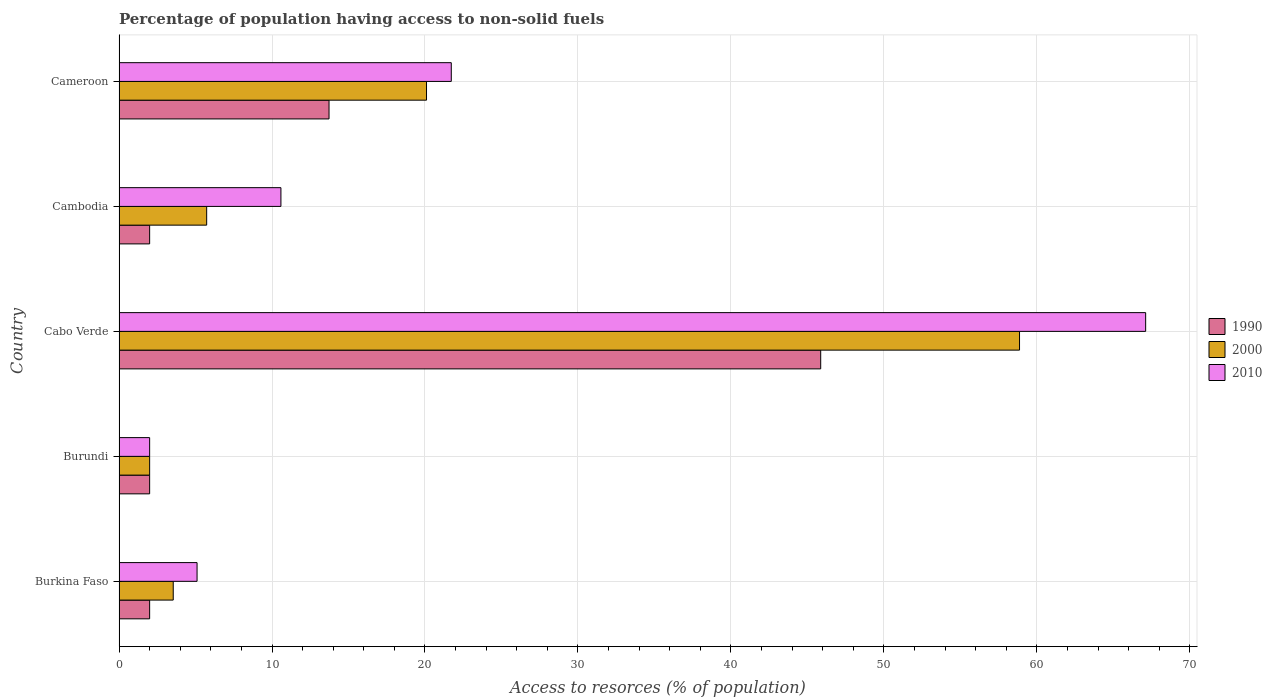How many different coloured bars are there?
Offer a very short reply. 3. Are the number of bars on each tick of the Y-axis equal?
Ensure brevity in your answer.  Yes. How many bars are there on the 1st tick from the bottom?
Offer a terse response. 3. What is the label of the 1st group of bars from the top?
Offer a very short reply. Cameroon. What is the percentage of population having access to non-solid fuels in 1990 in Cabo Verde?
Your answer should be compact. 45.87. Across all countries, what is the maximum percentage of population having access to non-solid fuels in 2000?
Provide a short and direct response. 58.87. Across all countries, what is the minimum percentage of population having access to non-solid fuels in 2000?
Your response must be concise. 2. In which country was the percentage of population having access to non-solid fuels in 2010 maximum?
Offer a very short reply. Cabo Verde. In which country was the percentage of population having access to non-solid fuels in 2010 minimum?
Give a very brief answer. Burundi. What is the total percentage of population having access to non-solid fuels in 1990 in the graph?
Make the answer very short. 65.6. What is the difference between the percentage of population having access to non-solid fuels in 2010 in Burkina Faso and that in Cameroon?
Your answer should be very brief. -16.62. What is the difference between the percentage of population having access to non-solid fuels in 2010 in Burkina Faso and the percentage of population having access to non-solid fuels in 1990 in Cabo Verde?
Provide a short and direct response. -40.77. What is the average percentage of population having access to non-solid fuels in 2010 per country?
Keep it short and to the point. 21.3. What is the difference between the percentage of population having access to non-solid fuels in 2000 and percentage of population having access to non-solid fuels in 1990 in Cameroon?
Ensure brevity in your answer.  6.37. What is the ratio of the percentage of population having access to non-solid fuels in 2010 in Burkina Faso to that in Burundi?
Make the answer very short. 2.55. Is the percentage of population having access to non-solid fuels in 1990 in Burkina Faso less than that in Burundi?
Offer a very short reply. No. Is the difference between the percentage of population having access to non-solid fuels in 2000 in Cambodia and Cameroon greater than the difference between the percentage of population having access to non-solid fuels in 1990 in Cambodia and Cameroon?
Ensure brevity in your answer.  No. What is the difference between the highest and the second highest percentage of population having access to non-solid fuels in 2010?
Your answer should be very brief. 45.4. What is the difference between the highest and the lowest percentage of population having access to non-solid fuels in 1990?
Offer a terse response. 43.87. In how many countries, is the percentage of population having access to non-solid fuels in 1990 greater than the average percentage of population having access to non-solid fuels in 1990 taken over all countries?
Ensure brevity in your answer.  2. Is the sum of the percentage of population having access to non-solid fuels in 1990 in Burundi and Cabo Verde greater than the maximum percentage of population having access to non-solid fuels in 2010 across all countries?
Keep it short and to the point. No. How many bars are there?
Provide a succinct answer. 15. Are all the bars in the graph horizontal?
Your response must be concise. Yes. How many countries are there in the graph?
Your response must be concise. 5. What is the difference between two consecutive major ticks on the X-axis?
Keep it short and to the point. 10. Are the values on the major ticks of X-axis written in scientific E-notation?
Ensure brevity in your answer.  No. Does the graph contain any zero values?
Keep it short and to the point. No. How are the legend labels stacked?
Make the answer very short. Vertical. What is the title of the graph?
Offer a terse response. Percentage of population having access to non-solid fuels. What is the label or title of the X-axis?
Your answer should be compact. Access to resorces (% of population). What is the Access to resorces (% of population) of 1990 in Burkina Faso?
Make the answer very short. 2. What is the Access to resorces (% of population) in 2000 in Burkina Faso?
Your answer should be very brief. 3.54. What is the Access to resorces (% of population) of 2010 in Burkina Faso?
Offer a terse response. 5.1. What is the Access to resorces (% of population) in 1990 in Burundi?
Provide a succinct answer. 2. What is the Access to resorces (% of population) of 2000 in Burundi?
Your answer should be very brief. 2. What is the Access to resorces (% of population) of 2010 in Burundi?
Your response must be concise. 2. What is the Access to resorces (% of population) in 1990 in Cabo Verde?
Provide a succinct answer. 45.87. What is the Access to resorces (% of population) of 2000 in Cabo Verde?
Your answer should be compact. 58.87. What is the Access to resorces (% of population) of 2010 in Cabo Verde?
Make the answer very short. 67.11. What is the Access to resorces (% of population) in 1990 in Cambodia?
Ensure brevity in your answer.  2. What is the Access to resorces (% of population) in 2000 in Cambodia?
Your answer should be very brief. 5.73. What is the Access to resorces (% of population) in 2010 in Cambodia?
Your answer should be compact. 10.58. What is the Access to resorces (% of population) of 1990 in Cameroon?
Ensure brevity in your answer.  13.73. What is the Access to resorces (% of population) of 2000 in Cameroon?
Keep it short and to the point. 20.1. What is the Access to resorces (% of population) of 2010 in Cameroon?
Give a very brief answer. 21.72. Across all countries, what is the maximum Access to resorces (% of population) in 1990?
Offer a terse response. 45.87. Across all countries, what is the maximum Access to resorces (% of population) in 2000?
Your answer should be very brief. 58.87. Across all countries, what is the maximum Access to resorces (% of population) of 2010?
Ensure brevity in your answer.  67.11. Across all countries, what is the minimum Access to resorces (% of population) in 1990?
Ensure brevity in your answer.  2. Across all countries, what is the minimum Access to resorces (% of population) of 2000?
Your answer should be very brief. 2. Across all countries, what is the minimum Access to resorces (% of population) of 2010?
Provide a short and direct response. 2. What is the total Access to resorces (% of population) in 1990 in the graph?
Provide a short and direct response. 65.6. What is the total Access to resorces (% of population) of 2000 in the graph?
Provide a short and direct response. 90.24. What is the total Access to resorces (% of population) in 2010 in the graph?
Give a very brief answer. 106.52. What is the difference between the Access to resorces (% of population) in 1990 in Burkina Faso and that in Burundi?
Keep it short and to the point. 0. What is the difference between the Access to resorces (% of population) in 2000 in Burkina Faso and that in Burundi?
Offer a terse response. 1.54. What is the difference between the Access to resorces (% of population) in 2010 in Burkina Faso and that in Burundi?
Your response must be concise. 3.1. What is the difference between the Access to resorces (% of population) in 1990 in Burkina Faso and that in Cabo Verde?
Your answer should be very brief. -43.87. What is the difference between the Access to resorces (% of population) of 2000 in Burkina Faso and that in Cabo Verde?
Give a very brief answer. -55.33. What is the difference between the Access to resorces (% of population) of 2010 in Burkina Faso and that in Cabo Verde?
Ensure brevity in your answer.  -62.01. What is the difference between the Access to resorces (% of population) in 1990 in Burkina Faso and that in Cambodia?
Provide a succinct answer. 0. What is the difference between the Access to resorces (% of population) in 2000 in Burkina Faso and that in Cambodia?
Your response must be concise. -2.19. What is the difference between the Access to resorces (% of population) in 2010 in Burkina Faso and that in Cambodia?
Give a very brief answer. -5.48. What is the difference between the Access to resorces (% of population) in 1990 in Burkina Faso and that in Cameroon?
Provide a succinct answer. -11.73. What is the difference between the Access to resorces (% of population) of 2000 in Burkina Faso and that in Cameroon?
Your response must be concise. -16.56. What is the difference between the Access to resorces (% of population) of 2010 in Burkina Faso and that in Cameroon?
Make the answer very short. -16.62. What is the difference between the Access to resorces (% of population) of 1990 in Burundi and that in Cabo Verde?
Provide a succinct answer. -43.87. What is the difference between the Access to resorces (% of population) in 2000 in Burundi and that in Cabo Verde?
Offer a very short reply. -56.87. What is the difference between the Access to resorces (% of population) in 2010 in Burundi and that in Cabo Verde?
Make the answer very short. -65.11. What is the difference between the Access to resorces (% of population) in 2000 in Burundi and that in Cambodia?
Give a very brief answer. -3.73. What is the difference between the Access to resorces (% of population) of 2010 in Burundi and that in Cambodia?
Provide a succinct answer. -8.58. What is the difference between the Access to resorces (% of population) in 1990 in Burundi and that in Cameroon?
Provide a succinct answer. -11.73. What is the difference between the Access to resorces (% of population) in 2000 in Burundi and that in Cameroon?
Offer a very short reply. -18.1. What is the difference between the Access to resorces (% of population) in 2010 in Burundi and that in Cameroon?
Make the answer very short. -19.72. What is the difference between the Access to resorces (% of population) in 1990 in Cabo Verde and that in Cambodia?
Offer a very short reply. 43.87. What is the difference between the Access to resorces (% of population) of 2000 in Cabo Verde and that in Cambodia?
Your answer should be very brief. 53.14. What is the difference between the Access to resorces (% of population) in 2010 in Cabo Verde and that in Cambodia?
Your answer should be very brief. 56.53. What is the difference between the Access to resorces (% of population) of 1990 in Cabo Verde and that in Cameroon?
Your answer should be very brief. 32.14. What is the difference between the Access to resorces (% of population) in 2000 in Cabo Verde and that in Cameroon?
Ensure brevity in your answer.  38.77. What is the difference between the Access to resorces (% of population) in 2010 in Cabo Verde and that in Cameroon?
Ensure brevity in your answer.  45.4. What is the difference between the Access to resorces (% of population) of 1990 in Cambodia and that in Cameroon?
Provide a succinct answer. -11.73. What is the difference between the Access to resorces (% of population) of 2000 in Cambodia and that in Cameroon?
Your answer should be compact. -14.37. What is the difference between the Access to resorces (% of population) in 2010 in Cambodia and that in Cameroon?
Offer a very short reply. -11.14. What is the difference between the Access to resorces (% of population) in 1990 in Burkina Faso and the Access to resorces (% of population) in 2000 in Burundi?
Provide a succinct answer. 0. What is the difference between the Access to resorces (% of population) of 1990 in Burkina Faso and the Access to resorces (% of population) of 2010 in Burundi?
Provide a succinct answer. 0. What is the difference between the Access to resorces (% of population) in 2000 in Burkina Faso and the Access to resorces (% of population) in 2010 in Burundi?
Your response must be concise. 1.54. What is the difference between the Access to resorces (% of population) of 1990 in Burkina Faso and the Access to resorces (% of population) of 2000 in Cabo Verde?
Provide a short and direct response. -56.87. What is the difference between the Access to resorces (% of population) in 1990 in Burkina Faso and the Access to resorces (% of population) in 2010 in Cabo Verde?
Make the answer very short. -65.11. What is the difference between the Access to resorces (% of population) in 2000 in Burkina Faso and the Access to resorces (% of population) in 2010 in Cabo Verde?
Make the answer very short. -63.57. What is the difference between the Access to resorces (% of population) of 1990 in Burkina Faso and the Access to resorces (% of population) of 2000 in Cambodia?
Give a very brief answer. -3.73. What is the difference between the Access to resorces (% of population) in 1990 in Burkina Faso and the Access to resorces (% of population) in 2010 in Cambodia?
Provide a short and direct response. -8.58. What is the difference between the Access to resorces (% of population) of 2000 in Burkina Faso and the Access to resorces (% of population) of 2010 in Cambodia?
Make the answer very short. -7.04. What is the difference between the Access to resorces (% of population) in 1990 in Burkina Faso and the Access to resorces (% of population) in 2000 in Cameroon?
Keep it short and to the point. -18.1. What is the difference between the Access to resorces (% of population) of 1990 in Burkina Faso and the Access to resorces (% of population) of 2010 in Cameroon?
Offer a very short reply. -19.72. What is the difference between the Access to resorces (% of population) of 2000 in Burkina Faso and the Access to resorces (% of population) of 2010 in Cameroon?
Your answer should be very brief. -18.18. What is the difference between the Access to resorces (% of population) of 1990 in Burundi and the Access to resorces (% of population) of 2000 in Cabo Verde?
Keep it short and to the point. -56.87. What is the difference between the Access to resorces (% of population) of 1990 in Burundi and the Access to resorces (% of population) of 2010 in Cabo Verde?
Provide a succinct answer. -65.11. What is the difference between the Access to resorces (% of population) in 2000 in Burundi and the Access to resorces (% of population) in 2010 in Cabo Verde?
Ensure brevity in your answer.  -65.11. What is the difference between the Access to resorces (% of population) of 1990 in Burundi and the Access to resorces (% of population) of 2000 in Cambodia?
Provide a short and direct response. -3.73. What is the difference between the Access to resorces (% of population) in 1990 in Burundi and the Access to resorces (% of population) in 2010 in Cambodia?
Make the answer very short. -8.58. What is the difference between the Access to resorces (% of population) in 2000 in Burundi and the Access to resorces (% of population) in 2010 in Cambodia?
Provide a succinct answer. -8.58. What is the difference between the Access to resorces (% of population) of 1990 in Burundi and the Access to resorces (% of population) of 2000 in Cameroon?
Your response must be concise. -18.1. What is the difference between the Access to resorces (% of population) in 1990 in Burundi and the Access to resorces (% of population) in 2010 in Cameroon?
Your answer should be very brief. -19.72. What is the difference between the Access to resorces (% of population) of 2000 in Burundi and the Access to resorces (% of population) of 2010 in Cameroon?
Give a very brief answer. -19.72. What is the difference between the Access to resorces (% of population) in 1990 in Cabo Verde and the Access to resorces (% of population) in 2000 in Cambodia?
Your answer should be compact. 40.14. What is the difference between the Access to resorces (% of population) of 1990 in Cabo Verde and the Access to resorces (% of population) of 2010 in Cambodia?
Your answer should be very brief. 35.29. What is the difference between the Access to resorces (% of population) of 2000 in Cabo Verde and the Access to resorces (% of population) of 2010 in Cambodia?
Keep it short and to the point. 48.29. What is the difference between the Access to resorces (% of population) of 1990 in Cabo Verde and the Access to resorces (% of population) of 2000 in Cameroon?
Your answer should be compact. 25.77. What is the difference between the Access to resorces (% of population) of 1990 in Cabo Verde and the Access to resorces (% of population) of 2010 in Cameroon?
Make the answer very short. 24.15. What is the difference between the Access to resorces (% of population) in 2000 in Cabo Verde and the Access to resorces (% of population) in 2010 in Cameroon?
Offer a terse response. 37.15. What is the difference between the Access to resorces (% of population) of 1990 in Cambodia and the Access to resorces (% of population) of 2000 in Cameroon?
Provide a succinct answer. -18.1. What is the difference between the Access to resorces (% of population) in 1990 in Cambodia and the Access to resorces (% of population) in 2010 in Cameroon?
Offer a very short reply. -19.72. What is the difference between the Access to resorces (% of population) in 2000 in Cambodia and the Access to resorces (% of population) in 2010 in Cameroon?
Make the answer very short. -15.99. What is the average Access to resorces (% of population) of 1990 per country?
Your response must be concise. 13.12. What is the average Access to resorces (% of population) in 2000 per country?
Ensure brevity in your answer.  18.05. What is the average Access to resorces (% of population) in 2010 per country?
Offer a very short reply. 21.3. What is the difference between the Access to resorces (% of population) in 1990 and Access to resorces (% of population) in 2000 in Burkina Faso?
Keep it short and to the point. -1.54. What is the difference between the Access to resorces (% of population) of 1990 and Access to resorces (% of population) of 2010 in Burkina Faso?
Your answer should be very brief. -3.1. What is the difference between the Access to resorces (% of population) of 2000 and Access to resorces (% of population) of 2010 in Burkina Faso?
Offer a terse response. -1.56. What is the difference between the Access to resorces (% of population) in 1990 and Access to resorces (% of population) in 2000 in Burundi?
Keep it short and to the point. 0. What is the difference between the Access to resorces (% of population) in 1990 and Access to resorces (% of population) in 2000 in Cabo Verde?
Provide a succinct answer. -13. What is the difference between the Access to resorces (% of population) of 1990 and Access to resorces (% of population) of 2010 in Cabo Verde?
Keep it short and to the point. -21.24. What is the difference between the Access to resorces (% of population) in 2000 and Access to resorces (% of population) in 2010 in Cabo Verde?
Ensure brevity in your answer.  -8.25. What is the difference between the Access to resorces (% of population) in 1990 and Access to resorces (% of population) in 2000 in Cambodia?
Offer a terse response. -3.73. What is the difference between the Access to resorces (% of population) in 1990 and Access to resorces (% of population) in 2010 in Cambodia?
Your response must be concise. -8.58. What is the difference between the Access to resorces (% of population) in 2000 and Access to resorces (% of population) in 2010 in Cambodia?
Provide a short and direct response. -4.85. What is the difference between the Access to resorces (% of population) of 1990 and Access to resorces (% of population) of 2000 in Cameroon?
Provide a short and direct response. -6.37. What is the difference between the Access to resorces (% of population) in 1990 and Access to resorces (% of population) in 2010 in Cameroon?
Offer a terse response. -7.99. What is the difference between the Access to resorces (% of population) of 2000 and Access to resorces (% of population) of 2010 in Cameroon?
Provide a short and direct response. -1.62. What is the ratio of the Access to resorces (% of population) in 2000 in Burkina Faso to that in Burundi?
Offer a very short reply. 1.77. What is the ratio of the Access to resorces (% of population) of 2010 in Burkina Faso to that in Burundi?
Make the answer very short. 2.55. What is the ratio of the Access to resorces (% of population) of 1990 in Burkina Faso to that in Cabo Verde?
Give a very brief answer. 0.04. What is the ratio of the Access to resorces (% of population) in 2000 in Burkina Faso to that in Cabo Verde?
Make the answer very short. 0.06. What is the ratio of the Access to resorces (% of population) of 2010 in Burkina Faso to that in Cabo Verde?
Your response must be concise. 0.08. What is the ratio of the Access to resorces (% of population) in 1990 in Burkina Faso to that in Cambodia?
Provide a short and direct response. 1. What is the ratio of the Access to resorces (% of population) of 2000 in Burkina Faso to that in Cambodia?
Offer a terse response. 0.62. What is the ratio of the Access to resorces (% of population) in 2010 in Burkina Faso to that in Cambodia?
Provide a succinct answer. 0.48. What is the ratio of the Access to resorces (% of population) in 1990 in Burkina Faso to that in Cameroon?
Ensure brevity in your answer.  0.15. What is the ratio of the Access to resorces (% of population) of 2000 in Burkina Faso to that in Cameroon?
Provide a succinct answer. 0.18. What is the ratio of the Access to resorces (% of population) in 2010 in Burkina Faso to that in Cameroon?
Your answer should be very brief. 0.23. What is the ratio of the Access to resorces (% of population) of 1990 in Burundi to that in Cabo Verde?
Ensure brevity in your answer.  0.04. What is the ratio of the Access to resorces (% of population) in 2000 in Burundi to that in Cabo Verde?
Keep it short and to the point. 0.03. What is the ratio of the Access to resorces (% of population) in 2010 in Burundi to that in Cabo Verde?
Your answer should be very brief. 0.03. What is the ratio of the Access to resorces (% of population) in 2000 in Burundi to that in Cambodia?
Keep it short and to the point. 0.35. What is the ratio of the Access to resorces (% of population) in 2010 in Burundi to that in Cambodia?
Offer a terse response. 0.19. What is the ratio of the Access to resorces (% of population) of 1990 in Burundi to that in Cameroon?
Provide a succinct answer. 0.15. What is the ratio of the Access to resorces (% of population) of 2000 in Burundi to that in Cameroon?
Your answer should be compact. 0.1. What is the ratio of the Access to resorces (% of population) of 2010 in Burundi to that in Cameroon?
Your response must be concise. 0.09. What is the ratio of the Access to resorces (% of population) of 1990 in Cabo Verde to that in Cambodia?
Your response must be concise. 22.93. What is the ratio of the Access to resorces (% of population) of 2000 in Cabo Verde to that in Cambodia?
Keep it short and to the point. 10.28. What is the ratio of the Access to resorces (% of population) of 2010 in Cabo Verde to that in Cambodia?
Provide a short and direct response. 6.34. What is the ratio of the Access to resorces (% of population) in 1990 in Cabo Verde to that in Cameroon?
Ensure brevity in your answer.  3.34. What is the ratio of the Access to resorces (% of population) in 2000 in Cabo Verde to that in Cameroon?
Give a very brief answer. 2.93. What is the ratio of the Access to resorces (% of population) in 2010 in Cabo Verde to that in Cameroon?
Offer a very short reply. 3.09. What is the ratio of the Access to resorces (% of population) in 1990 in Cambodia to that in Cameroon?
Offer a very short reply. 0.15. What is the ratio of the Access to resorces (% of population) in 2000 in Cambodia to that in Cameroon?
Give a very brief answer. 0.28. What is the ratio of the Access to resorces (% of population) of 2010 in Cambodia to that in Cameroon?
Give a very brief answer. 0.49. What is the difference between the highest and the second highest Access to resorces (% of population) in 1990?
Give a very brief answer. 32.14. What is the difference between the highest and the second highest Access to resorces (% of population) in 2000?
Give a very brief answer. 38.77. What is the difference between the highest and the second highest Access to resorces (% of population) in 2010?
Give a very brief answer. 45.4. What is the difference between the highest and the lowest Access to resorces (% of population) of 1990?
Keep it short and to the point. 43.87. What is the difference between the highest and the lowest Access to resorces (% of population) of 2000?
Provide a short and direct response. 56.87. What is the difference between the highest and the lowest Access to resorces (% of population) in 2010?
Ensure brevity in your answer.  65.11. 